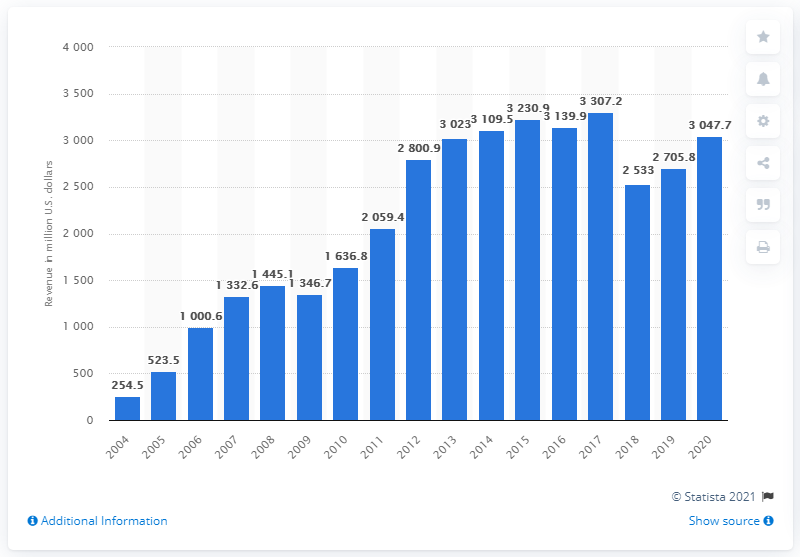Give some essential details in this illustration. In 2020, IAC's revenue was 3047.7 million dollars. 